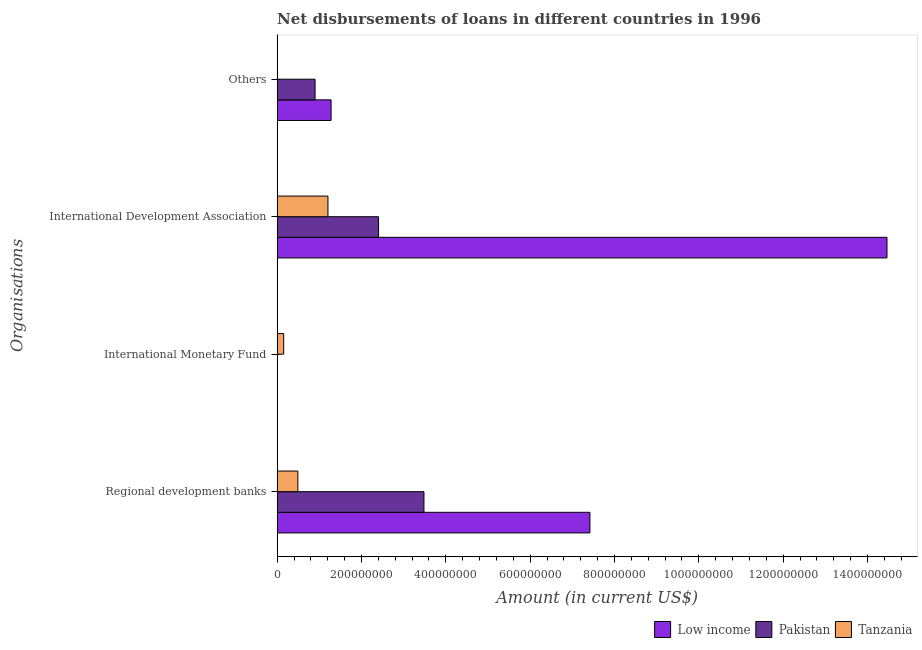Are the number of bars per tick equal to the number of legend labels?
Offer a very short reply. No. How many bars are there on the 1st tick from the top?
Your answer should be very brief. 2. What is the label of the 3rd group of bars from the top?
Make the answer very short. International Monetary Fund. Across all countries, what is the maximum amount of loan disimbursed by international development association?
Ensure brevity in your answer.  1.45e+09. Across all countries, what is the minimum amount of loan disimbursed by regional development banks?
Keep it short and to the point. 4.92e+07. In which country was the amount of loan disimbursed by international monetary fund maximum?
Make the answer very short. Tanzania. What is the total amount of loan disimbursed by other organisations in the graph?
Give a very brief answer. 2.18e+08. What is the difference between the amount of loan disimbursed by other organisations in Pakistan and that in Low income?
Your answer should be compact. -3.80e+07. What is the difference between the amount of loan disimbursed by international monetary fund in Low income and the amount of loan disimbursed by other organisations in Pakistan?
Give a very brief answer. -9.00e+07. What is the average amount of loan disimbursed by international development association per country?
Offer a very short reply. 6.02e+08. What is the difference between the amount of loan disimbursed by regional development banks and amount of loan disimbursed by international development association in Low income?
Ensure brevity in your answer.  -7.04e+08. What is the ratio of the amount of loan disimbursed by international development association in Tanzania to that in Low income?
Provide a short and direct response. 0.08. What is the difference between the highest and the lowest amount of loan disimbursed by regional development banks?
Your answer should be very brief. 6.93e+08. Is the sum of the amount of loan disimbursed by international development association in Pakistan and Low income greater than the maximum amount of loan disimbursed by international monetary fund across all countries?
Provide a succinct answer. Yes. Are all the bars in the graph horizontal?
Give a very brief answer. Yes. Does the graph contain any zero values?
Make the answer very short. Yes. Does the graph contain grids?
Offer a very short reply. No. Where does the legend appear in the graph?
Offer a terse response. Bottom right. What is the title of the graph?
Provide a succinct answer. Net disbursements of loans in different countries in 1996. What is the label or title of the Y-axis?
Your answer should be compact. Organisations. What is the Amount (in current US$) in Low income in Regional development banks?
Provide a short and direct response. 7.42e+08. What is the Amount (in current US$) of Pakistan in Regional development banks?
Provide a succinct answer. 3.48e+08. What is the Amount (in current US$) in Tanzania in Regional development banks?
Offer a terse response. 4.92e+07. What is the Amount (in current US$) in Tanzania in International Monetary Fund?
Your answer should be compact. 1.56e+07. What is the Amount (in current US$) in Low income in International Development Association?
Your response must be concise. 1.45e+09. What is the Amount (in current US$) in Pakistan in International Development Association?
Your answer should be compact. 2.41e+08. What is the Amount (in current US$) in Tanzania in International Development Association?
Provide a succinct answer. 1.21e+08. What is the Amount (in current US$) in Low income in Others?
Make the answer very short. 1.28e+08. What is the Amount (in current US$) of Pakistan in Others?
Keep it short and to the point. 9.00e+07. Across all Organisations, what is the maximum Amount (in current US$) in Low income?
Provide a short and direct response. 1.45e+09. Across all Organisations, what is the maximum Amount (in current US$) in Pakistan?
Your answer should be very brief. 3.48e+08. Across all Organisations, what is the maximum Amount (in current US$) in Tanzania?
Give a very brief answer. 1.21e+08. Across all Organisations, what is the minimum Amount (in current US$) of Low income?
Your response must be concise. 0. Across all Organisations, what is the minimum Amount (in current US$) of Tanzania?
Your answer should be compact. 0. What is the total Amount (in current US$) in Low income in the graph?
Ensure brevity in your answer.  2.32e+09. What is the total Amount (in current US$) of Pakistan in the graph?
Provide a succinct answer. 6.79e+08. What is the total Amount (in current US$) in Tanzania in the graph?
Your answer should be very brief. 1.85e+08. What is the difference between the Amount (in current US$) in Tanzania in Regional development banks and that in International Monetary Fund?
Provide a succinct answer. 3.36e+07. What is the difference between the Amount (in current US$) of Low income in Regional development banks and that in International Development Association?
Provide a short and direct response. -7.04e+08. What is the difference between the Amount (in current US$) of Pakistan in Regional development banks and that in International Development Association?
Offer a terse response. 1.08e+08. What is the difference between the Amount (in current US$) of Tanzania in Regional development banks and that in International Development Association?
Offer a terse response. -7.13e+07. What is the difference between the Amount (in current US$) in Low income in Regional development banks and that in Others?
Make the answer very short. 6.14e+08. What is the difference between the Amount (in current US$) in Pakistan in Regional development banks and that in Others?
Keep it short and to the point. 2.58e+08. What is the difference between the Amount (in current US$) of Tanzania in International Monetary Fund and that in International Development Association?
Make the answer very short. -1.05e+08. What is the difference between the Amount (in current US$) of Low income in International Development Association and that in Others?
Make the answer very short. 1.32e+09. What is the difference between the Amount (in current US$) of Pakistan in International Development Association and that in Others?
Offer a very short reply. 1.51e+08. What is the difference between the Amount (in current US$) in Low income in Regional development banks and the Amount (in current US$) in Tanzania in International Monetary Fund?
Make the answer very short. 7.26e+08. What is the difference between the Amount (in current US$) in Pakistan in Regional development banks and the Amount (in current US$) in Tanzania in International Monetary Fund?
Offer a terse response. 3.33e+08. What is the difference between the Amount (in current US$) of Low income in Regional development banks and the Amount (in current US$) of Pakistan in International Development Association?
Give a very brief answer. 5.01e+08. What is the difference between the Amount (in current US$) in Low income in Regional development banks and the Amount (in current US$) in Tanzania in International Development Association?
Provide a succinct answer. 6.21e+08. What is the difference between the Amount (in current US$) in Pakistan in Regional development banks and the Amount (in current US$) in Tanzania in International Development Association?
Ensure brevity in your answer.  2.28e+08. What is the difference between the Amount (in current US$) of Low income in Regional development banks and the Amount (in current US$) of Pakistan in Others?
Give a very brief answer. 6.52e+08. What is the difference between the Amount (in current US$) of Low income in International Development Association and the Amount (in current US$) of Pakistan in Others?
Offer a very short reply. 1.36e+09. What is the average Amount (in current US$) of Low income per Organisations?
Ensure brevity in your answer.  5.79e+08. What is the average Amount (in current US$) in Pakistan per Organisations?
Give a very brief answer. 1.70e+08. What is the average Amount (in current US$) of Tanzania per Organisations?
Provide a short and direct response. 4.63e+07. What is the difference between the Amount (in current US$) of Low income and Amount (in current US$) of Pakistan in Regional development banks?
Ensure brevity in your answer.  3.94e+08. What is the difference between the Amount (in current US$) in Low income and Amount (in current US$) in Tanzania in Regional development banks?
Make the answer very short. 6.93e+08. What is the difference between the Amount (in current US$) of Pakistan and Amount (in current US$) of Tanzania in Regional development banks?
Keep it short and to the point. 2.99e+08. What is the difference between the Amount (in current US$) of Low income and Amount (in current US$) of Pakistan in International Development Association?
Provide a succinct answer. 1.21e+09. What is the difference between the Amount (in current US$) in Low income and Amount (in current US$) in Tanzania in International Development Association?
Give a very brief answer. 1.33e+09. What is the difference between the Amount (in current US$) in Pakistan and Amount (in current US$) in Tanzania in International Development Association?
Offer a very short reply. 1.20e+08. What is the difference between the Amount (in current US$) in Low income and Amount (in current US$) in Pakistan in Others?
Provide a short and direct response. 3.80e+07. What is the ratio of the Amount (in current US$) of Tanzania in Regional development banks to that in International Monetary Fund?
Provide a short and direct response. 3.16. What is the ratio of the Amount (in current US$) of Low income in Regional development banks to that in International Development Association?
Offer a very short reply. 0.51. What is the ratio of the Amount (in current US$) of Pakistan in Regional development banks to that in International Development Association?
Provide a succinct answer. 1.45. What is the ratio of the Amount (in current US$) of Tanzania in Regional development banks to that in International Development Association?
Your answer should be very brief. 0.41. What is the ratio of the Amount (in current US$) of Low income in Regional development banks to that in Others?
Your answer should be compact. 5.8. What is the ratio of the Amount (in current US$) of Pakistan in Regional development banks to that in Others?
Give a very brief answer. 3.87. What is the ratio of the Amount (in current US$) of Tanzania in International Monetary Fund to that in International Development Association?
Offer a very short reply. 0.13. What is the ratio of the Amount (in current US$) in Low income in International Development Association to that in Others?
Your answer should be compact. 11.3. What is the ratio of the Amount (in current US$) of Pakistan in International Development Association to that in Others?
Make the answer very short. 2.67. What is the difference between the highest and the second highest Amount (in current US$) of Low income?
Offer a very short reply. 7.04e+08. What is the difference between the highest and the second highest Amount (in current US$) in Pakistan?
Give a very brief answer. 1.08e+08. What is the difference between the highest and the second highest Amount (in current US$) of Tanzania?
Make the answer very short. 7.13e+07. What is the difference between the highest and the lowest Amount (in current US$) of Low income?
Provide a succinct answer. 1.45e+09. What is the difference between the highest and the lowest Amount (in current US$) of Pakistan?
Offer a very short reply. 3.48e+08. What is the difference between the highest and the lowest Amount (in current US$) in Tanzania?
Your response must be concise. 1.21e+08. 